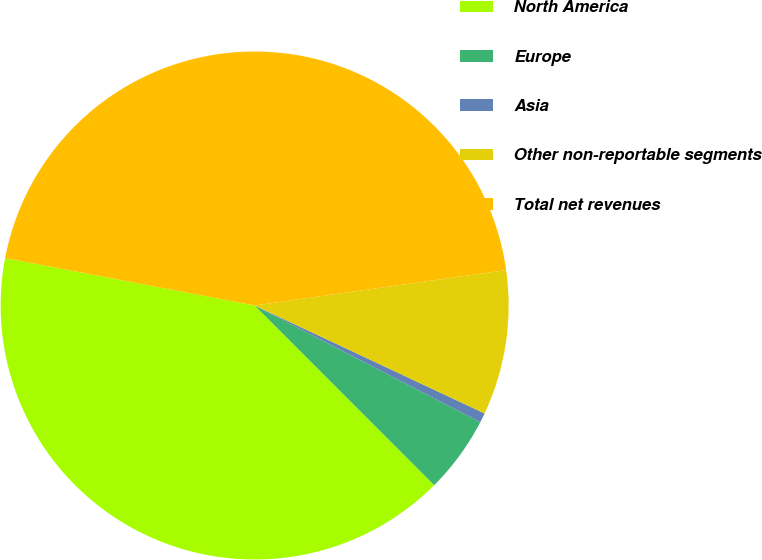Convert chart to OTSL. <chart><loc_0><loc_0><loc_500><loc_500><pie_chart><fcel>North America<fcel>Europe<fcel>Asia<fcel>Other non-reportable segments<fcel>Total net revenues<nl><fcel>40.48%<fcel>4.91%<fcel>0.61%<fcel>9.21%<fcel>44.78%<nl></chart> 